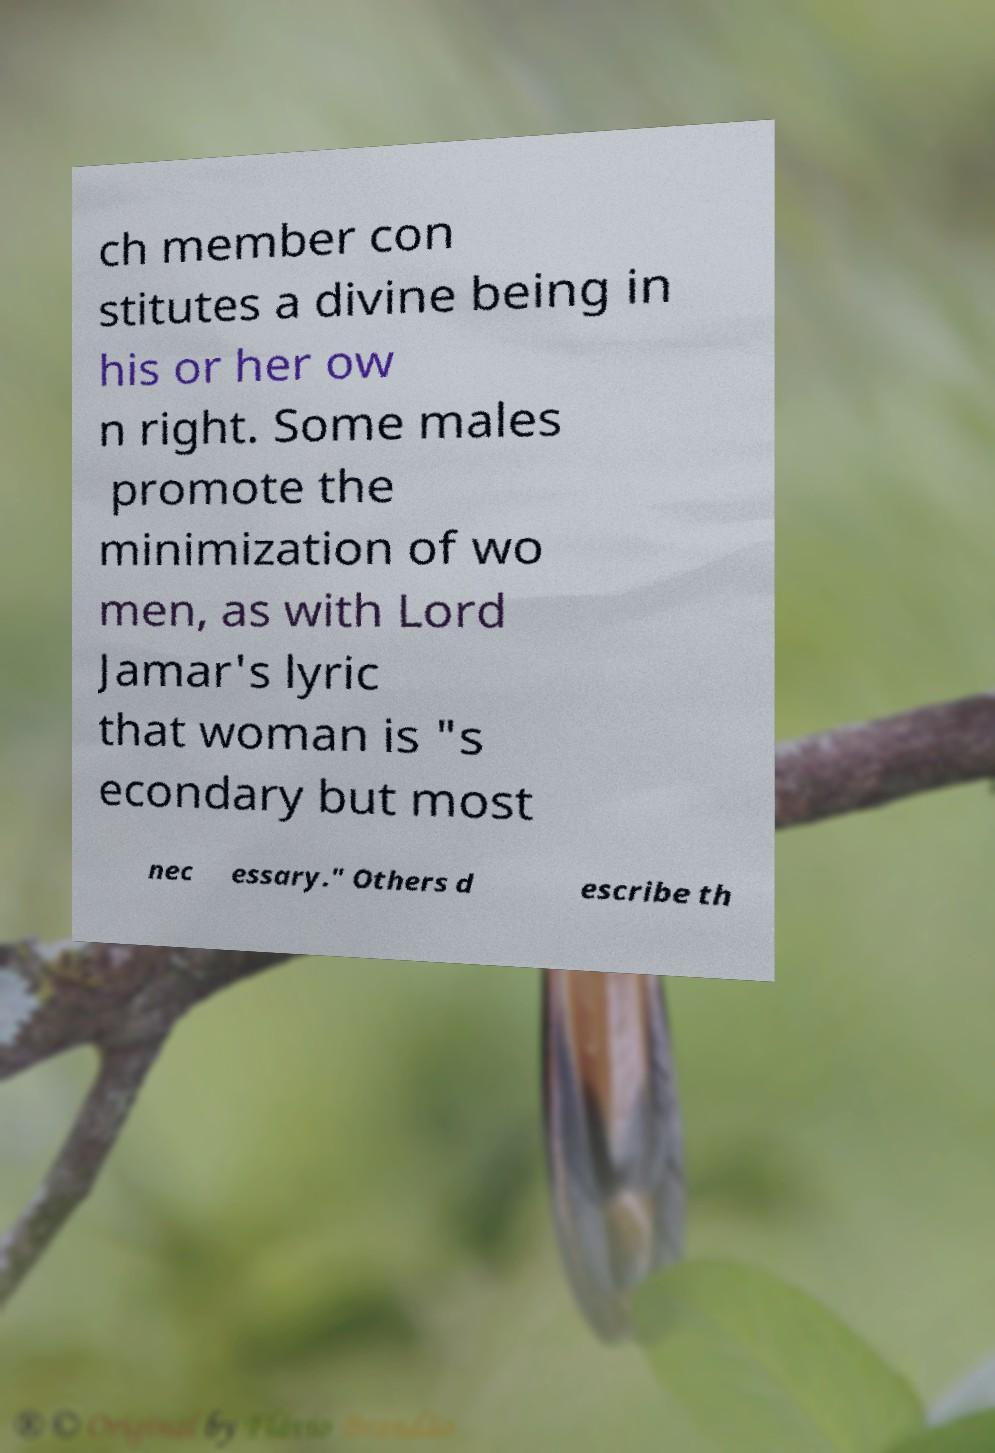What messages or text are displayed in this image? I need them in a readable, typed format. ch member con stitutes a divine being in his or her ow n right. Some males promote the minimization of wo men, as with Lord Jamar's lyric that woman is "s econdary but most nec essary." Others d escribe th 